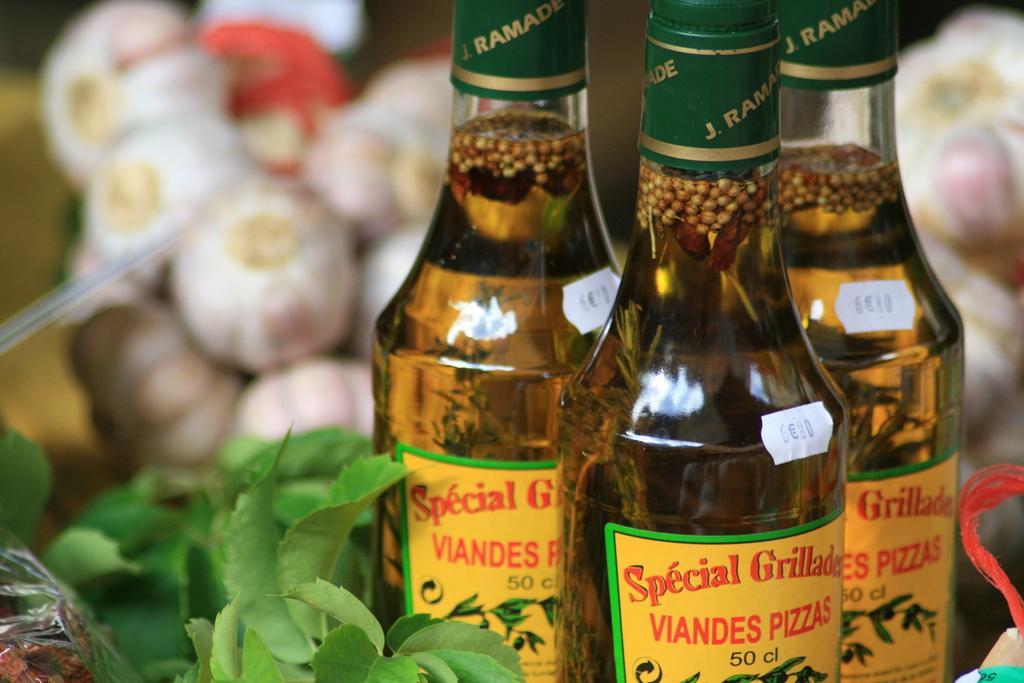Could you give a brief overview of what you see in this image? In this image there are three bottles and at the background of the image there are some vegetables. 